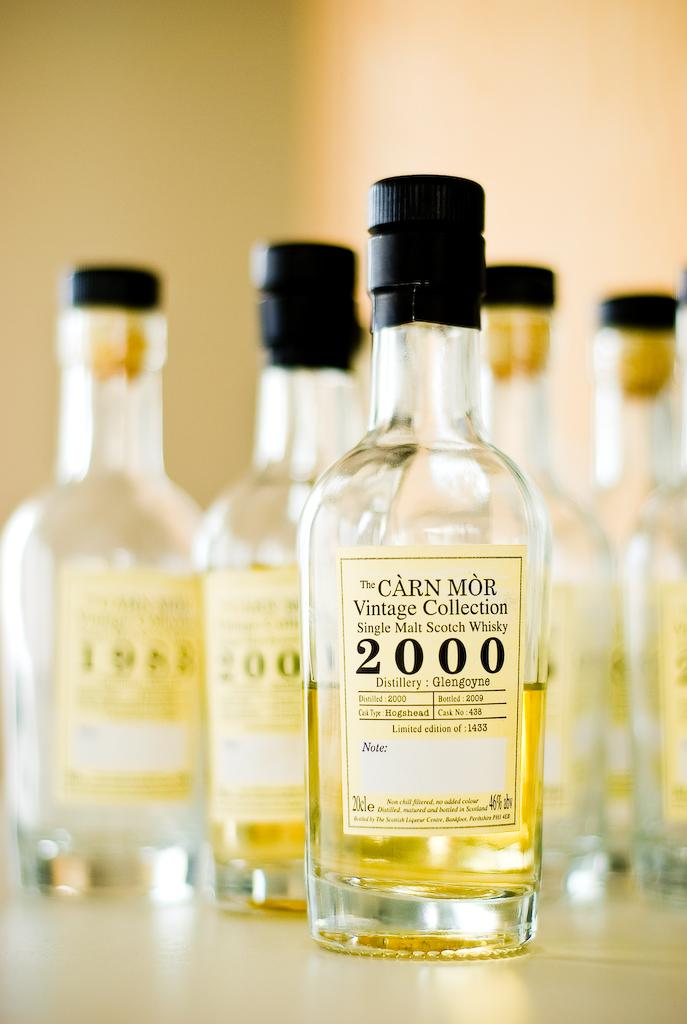Provide a one-sentence caption for the provided image. A cluster of bottles from the Carn Mor Vintage Collection of Single Malt Scotch Whisky. 